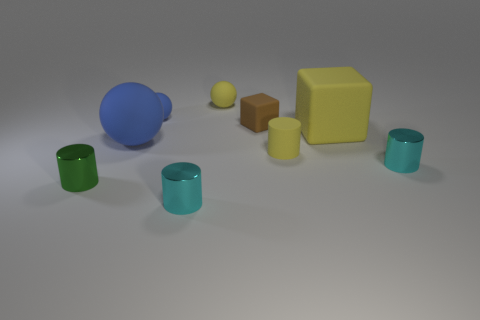Add 1 red rubber balls. How many objects exist? 10 Subtract all cubes. How many objects are left? 7 Subtract 1 cubes. How many cubes are left? 1 Subtract all yellow spheres. How many spheres are left? 2 Subtract all blue balls. How many balls are left? 1 Subtract all blue spheres. Subtract all brown blocks. How many spheres are left? 1 Subtract all brown cubes. How many cyan cylinders are left? 2 Subtract all blue rubber balls. Subtract all small yellow rubber objects. How many objects are left? 5 Add 2 brown blocks. How many brown blocks are left? 3 Add 7 matte cylinders. How many matte cylinders exist? 8 